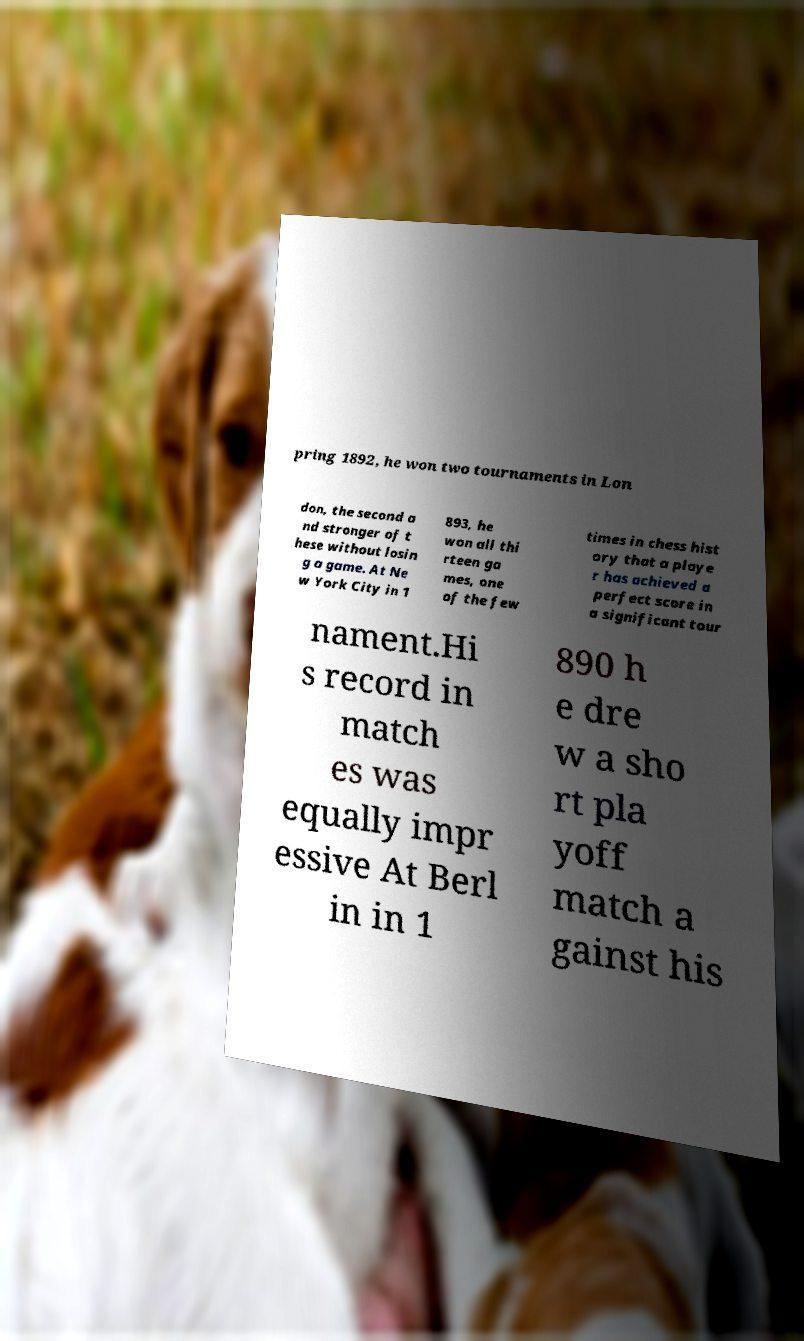Could you extract and type out the text from this image? pring 1892, he won two tournaments in Lon don, the second a nd stronger of t hese without losin g a game. At Ne w York City in 1 893, he won all thi rteen ga mes, one of the few times in chess hist ory that a playe r has achieved a perfect score in a significant tour nament.Hi s record in match es was equally impr essive At Berl in in 1 890 h e dre w a sho rt pla yoff match a gainst his 